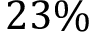<formula> <loc_0><loc_0><loc_500><loc_500>2 3 \%</formula> 